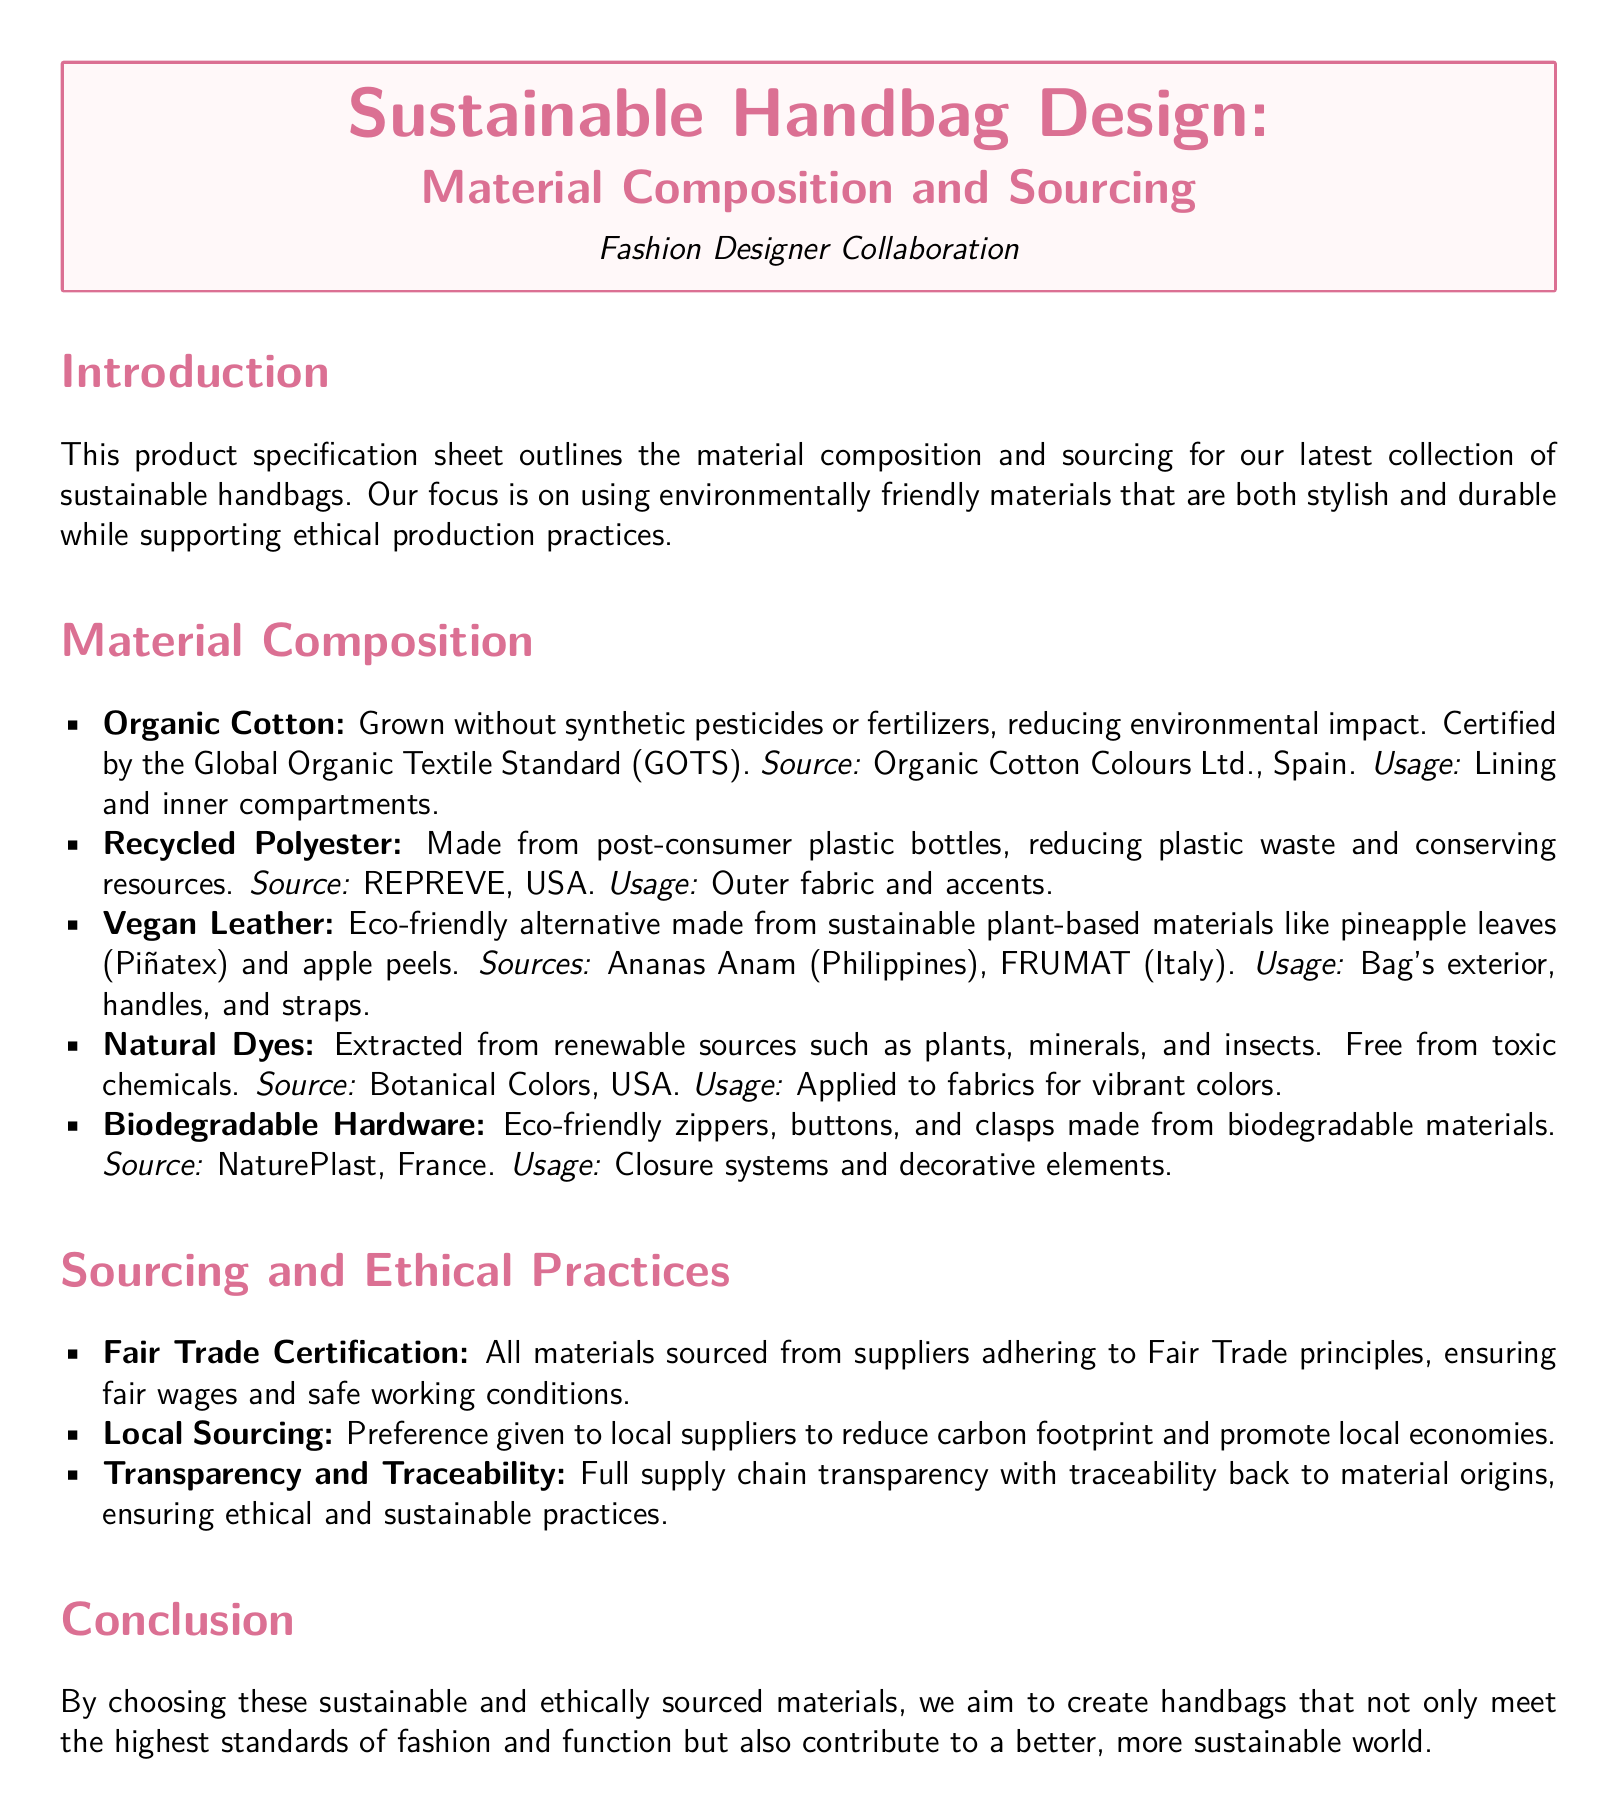what materials are used for the bag's exterior? The bag's exterior is made from vegan leather.
Answer: vegan leather which organization certifies organic cotton? Organic cotton is certified by the Global Organic Textile Standard.
Answer: Global Organic Textile Standard (GOTS) what type of dyes are used in the handbags? The handbags use natural dyes.
Answer: natural dyes what is the source of the recycled polyester? The source of recycled polyester is REPREVE, USA.
Answer: REPREVE, USA how does the company ensure ethical practices in sourcing? The company ensures ethical practices by sourcing materials from suppliers adhering to Fair Trade principles.
Answer: Fair Trade principles what type of materials are used for biodegradable hardware? Biodegradable hardware is made from eco-friendly materials.
Answer: eco-friendly materials where does the vegan leather come from? The vegan leather comes from Ananas Anam in the Philippines and FRUMAT in Italy.
Answer: Ananas Anam, Philippines; FRUMAT, Italy what is the focus of the handbag collection? The focus of the handbag collection is on using environmentally friendly materials.
Answer: environmentally friendly materials how does the company promote local economies? The company promotes local economies by giving preference to local suppliers.
Answer: local suppliers 